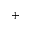<formula> <loc_0><loc_0><loc_500><loc_500>+</formula> 